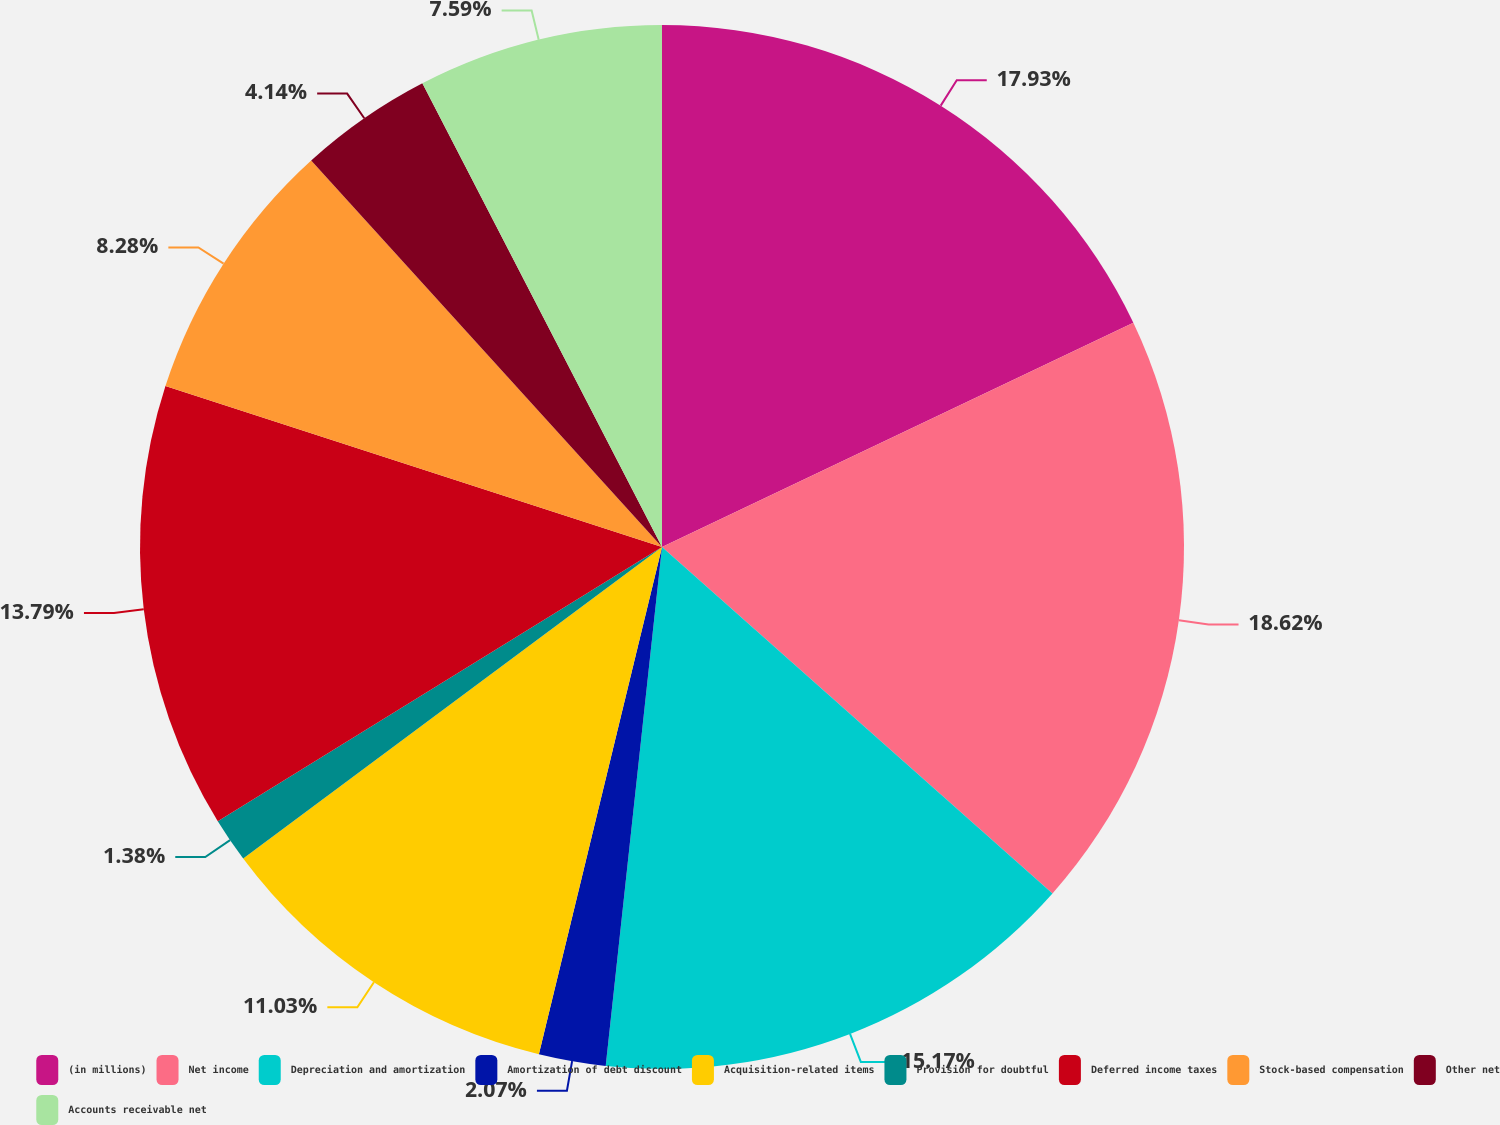Convert chart. <chart><loc_0><loc_0><loc_500><loc_500><pie_chart><fcel>(in millions)<fcel>Net income<fcel>Depreciation and amortization<fcel>Amortization of debt discount<fcel>Acquisition-related items<fcel>Provision for doubtful<fcel>Deferred income taxes<fcel>Stock-based compensation<fcel>Other net<fcel>Accounts receivable net<nl><fcel>17.93%<fcel>18.62%<fcel>15.17%<fcel>2.07%<fcel>11.03%<fcel>1.38%<fcel>13.79%<fcel>8.28%<fcel>4.14%<fcel>7.59%<nl></chart> 